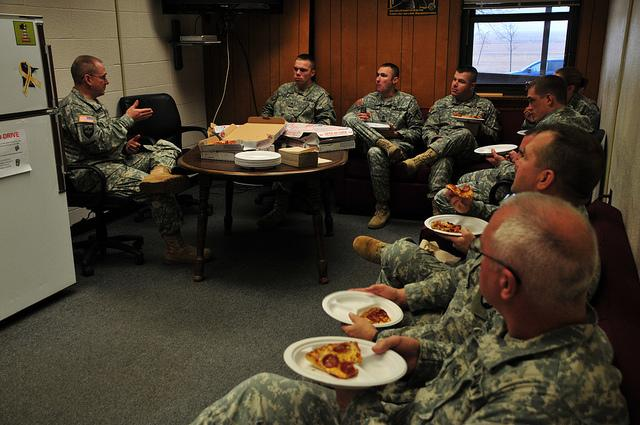What are they doing? Please explain your reasoning. eating pizza. They're having pizza. 